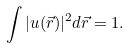<formula> <loc_0><loc_0><loc_500><loc_500>\int | u ( \vec { r } ) | ^ { 2 } d \vec { r } = 1 .</formula> 